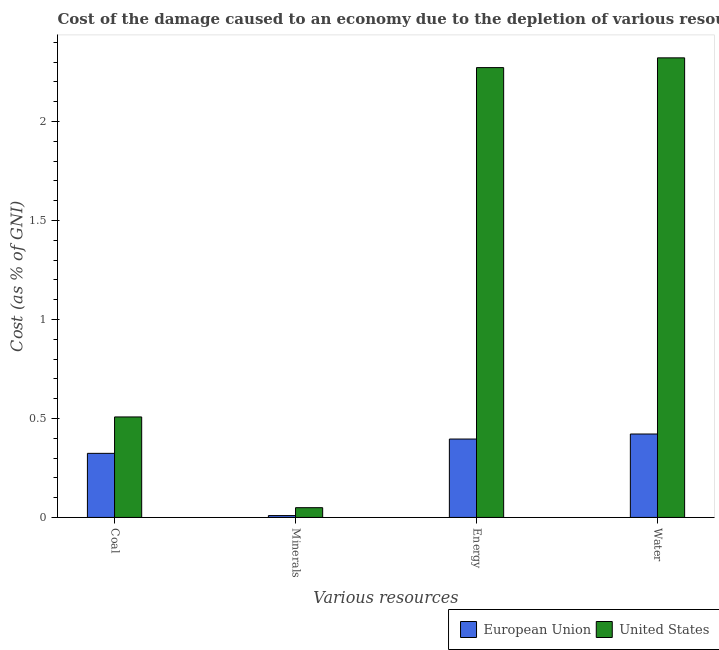How many groups of bars are there?
Provide a succinct answer. 4. Are the number of bars per tick equal to the number of legend labels?
Provide a short and direct response. Yes. Are the number of bars on each tick of the X-axis equal?
Offer a terse response. Yes. How many bars are there on the 3rd tick from the right?
Your answer should be compact. 2. What is the label of the 2nd group of bars from the left?
Make the answer very short. Minerals. What is the cost of damage due to depletion of coal in United States?
Keep it short and to the point. 0.51. Across all countries, what is the maximum cost of damage due to depletion of minerals?
Your answer should be compact. 0.05. Across all countries, what is the minimum cost of damage due to depletion of minerals?
Keep it short and to the point. 0.01. In which country was the cost of damage due to depletion of energy maximum?
Offer a terse response. United States. What is the total cost of damage due to depletion of energy in the graph?
Offer a terse response. 2.67. What is the difference between the cost of damage due to depletion of water in European Union and that in United States?
Your answer should be compact. -1.9. What is the difference between the cost of damage due to depletion of coal in United States and the cost of damage due to depletion of minerals in European Union?
Offer a very short reply. 0.5. What is the average cost of damage due to depletion of minerals per country?
Your answer should be compact. 0.03. What is the difference between the cost of damage due to depletion of energy and cost of damage due to depletion of minerals in European Union?
Offer a terse response. 0.39. In how many countries, is the cost of damage due to depletion of water greater than 1.1 %?
Your answer should be compact. 1. What is the ratio of the cost of damage due to depletion of water in European Union to that in United States?
Offer a terse response. 0.18. What is the difference between the highest and the second highest cost of damage due to depletion of minerals?
Make the answer very short. 0.04. What is the difference between the highest and the lowest cost of damage due to depletion of coal?
Provide a short and direct response. 0.18. In how many countries, is the cost of damage due to depletion of coal greater than the average cost of damage due to depletion of coal taken over all countries?
Give a very brief answer. 1. Is it the case that in every country, the sum of the cost of damage due to depletion of coal and cost of damage due to depletion of energy is greater than the sum of cost of damage due to depletion of minerals and cost of damage due to depletion of water?
Offer a terse response. No. What does the 1st bar from the left in Minerals represents?
Keep it short and to the point. European Union. What does the 1st bar from the right in Energy represents?
Offer a very short reply. United States. Is it the case that in every country, the sum of the cost of damage due to depletion of coal and cost of damage due to depletion of minerals is greater than the cost of damage due to depletion of energy?
Ensure brevity in your answer.  No. How many countries are there in the graph?
Make the answer very short. 2. Does the graph contain any zero values?
Offer a terse response. No. Does the graph contain grids?
Your answer should be compact. No. Where does the legend appear in the graph?
Make the answer very short. Bottom right. How many legend labels are there?
Give a very brief answer. 2. How are the legend labels stacked?
Make the answer very short. Horizontal. What is the title of the graph?
Give a very brief answer. Cost of the damage caused to an economy due to the depletion of various resources in 1977 . Does "Korea (Republic)" appear as one of the legend labels in the graph?
Ensure brevity in your answer.  No. What is the label or title of the X-axis?
Offer a terse response. Various resources. What is the label or title of the Y-axis?
Provide a short and direct response. Cost (as % of GNI). What is the Cost (as % of GNI) in European Union in Coal?
Offer a very short reply. 0.32. What is the Cost (as % of GNI) of United States in Coal?
Offer a terse response. 0.51. What is the Cost (as % of GNI) of European Union in Minerals?
Keep it short and to the point. 0.01. What is the Cost (as % of GNI) in United States in Minerals?
Your answer should be very brief. 0.05. What is the Cost (as % of GNI) of European Union in Energy?
Give a very brief answer. 0.4. What is the Cost (as % of GNI) in United States in Energy?
Offer a very short reply. 2.27. What is the Cost (as % of GNI) of European Union in Water?
Provide a succinct answer. 0.42. What is the Cost (as % of GNI) in United States in Water?
Your answer should be compact. 2.32. Across all Various resources, what is the maximum Cost (as % of GNI) of European Union?
Your response must be concise. 0.42. Across all Various resources, what is the maximum Cost (as % of GNI) in United States?
Your response must be concise. 2.32. Across all Various resources, what is the minimum Cost (as % of GNI) of European Union?
Offer a terse response. 0.01. Across all Various resources, what is the minimum Cost (as % of GNI) in United States?
Provide a short and direct response. 0.05. What is the total Cost (as % of GNI) in European Union in the graph?
Offer a terse response. 1.15. What is the total Cost (as % of GNI) in United States in the graph?
Ensure brevity in your answer.  5.15. What is the difference between the Cost (as % of GNI) of European Union in Coal and that in Minerals?
Your answer should be compact. 0.31. What is the difference between the Cost (as % of GNI) of United States in Coal and that in Minerals?
Ensure brevity in your answer.  0.46. What is the difference between the Cost (as % of GNI) in European Union in Coal and that in Energy?
Provide a succinct answer. -0.07. What is the difference between the Cost (as % of GNI) in United States in Coal and that in Energy?
Provide a short and direct response. -1.76. What is the difference between the Cost (as % of GNI) of European Union in Coal and that in Water?
Offer a very short reply. -0.1. What is the difference between the Cost (as % of GNI) of United States in Coal and that in Water?
Offer a very short reply. -1.81. What is the difference between the Cost (as % of GNI) in European Union in Minerals and that in Energy?
Give a very brief answer. -0.39. What is the difference between the Cost (as % of GNI) in United States in Minerals and that in Energy?
Offer a very short reply. -2.22. What is the difference between the Cost (as % of GNI) in European Union in Minerals and that in Water?
Ensure brevity in your answer.  -0.41. What is the difference between the Cost (as % of GNI) in United States in Minerals and that in Water?
Your answer should be compact. -2.27. What is the difference between the Cost (as % of GNI) of European Union in Energy and that in Water?
Offer a very short reply. -0.03. What is the difference between the Cost (as % of GNI) in United States in Energy and that in Water?
Your answer should be very brief. -0.05. What is the difference between the Cost (as % of GNI) of European Union in Coal and the Cost (as % of GNI) of United States in Minerals?
Your answer should be very brief. 0.27. What is the difference between the Cost (as % of GNI) of European Union in Coal and the Cost (as % of GNI) of United States in Energy?
Offer a very short reply. -1.95. What is the difference between the Cost (as % of GNI) in European Union in Coal and the Cost (as % of GNI) in United States in Water?
Provide a short and direct response. -2. What is the difference between the Cost (as % of GNI) of European Union in Minerals and the Cost (as % of GNI) of United States in Energy?
Your answer should be compact. -2.26. What is the difference between the Cost (as % of GNI) in European Union in Minerals and the Cost (as % of GNI) in United States in Water?
Your response must be concise. -2.31. What is the difference between the Cost (as % of GNI) in European Union in Energy and the Cost (as % of GNI) in United States in Water?
Provide a succinct answer. -1.93. What is the average Cost (as % of GNI) in European Union per Various resources?
Offer a very short reply. 0.29. What is the average Cost (as % of GNI) in United States per Various resources?
Your answer should be very brief. 1.29. What is the difference between the Cost (as % of GNI) of European Union and Cost (as % of GNI) of United States in Coal?
Offer a very short reply. -0.18. What is the difference between the Cost (as % of GNI) of European Union and Cost (as % of GNI) of United States in Minerals?
Make the answer very short. -0.04. What is the difference between the Cost (as % of GNI) of European Union and Cost (as % of GNI) of United States in Energy?
Provide a short and direct response. -1.88. What is the ratio of the Cost (as % of GNI) of European Union in Coal to that in Minerals?
Keep it short and to the point. 34.55. What is the ratio of the Cost (as % of GNI) of United States in Coal to that in Minerals?
Your response must be concise. 10.31. What is the ratio of the Cost (as % of GNI) in European Union in Coal to that in Energy?
Keep it short and to the point. 0.82. What is the ratio of the Cost (as % of GNI) of United States in Coal to that in Energy?
Make the answer very short. 0.22. What is the ratio of the Cost (as % of GNI) of European Union in Coal to that in Water?
Your response must be concise. 0.77. What is the ratio of the Cost (as % of GNI) of United States in Coal to that in Water?
Give a very brief answer. 0.22. What is the ratio of the Cost (as % of GNI) in European Union in Minerals to that in Energy?
Your response must be concise. 0.02. What is the ratio of the Cost (as % of GNI) in United States in Minerals to that in Energy?
Provide a succinct answer. 0.02. What is the ratio of the Cost (as % of GNI) of European Union in Minerals to that in Water?
Your answer should be compact. 0.02. What is the ratio of the Cost (as % of GNI) in United States in Minerals to that in Water?
Offer a very short reply. 0.02. What is the ratio of the Cost (as % of GNI) in European Union in Energy to that in Water?
Your answer should be very brief. 0.94. What is the ratio of the Cost (as % of GNI) of United States in Energy to that in Water?
Ensure brevity in your answer.  0.98. What is the difference between the highest and the second highest Cost (as % of GNI) in European Union?
Provide a short and direct response. 0.03. What is the difference between the highest and the second highest Cost (as % of GNI) of United States?
Ensure brevity in your answer.  0.05. What is the difference between the highest and the lowest Cost (as % of GNI) in European Union?
Provide a succinct answer. 0.41. What is the difference between the highest and the lowest Cost (as % of GNI) of United States?
Your response must be concise. 2.27. 